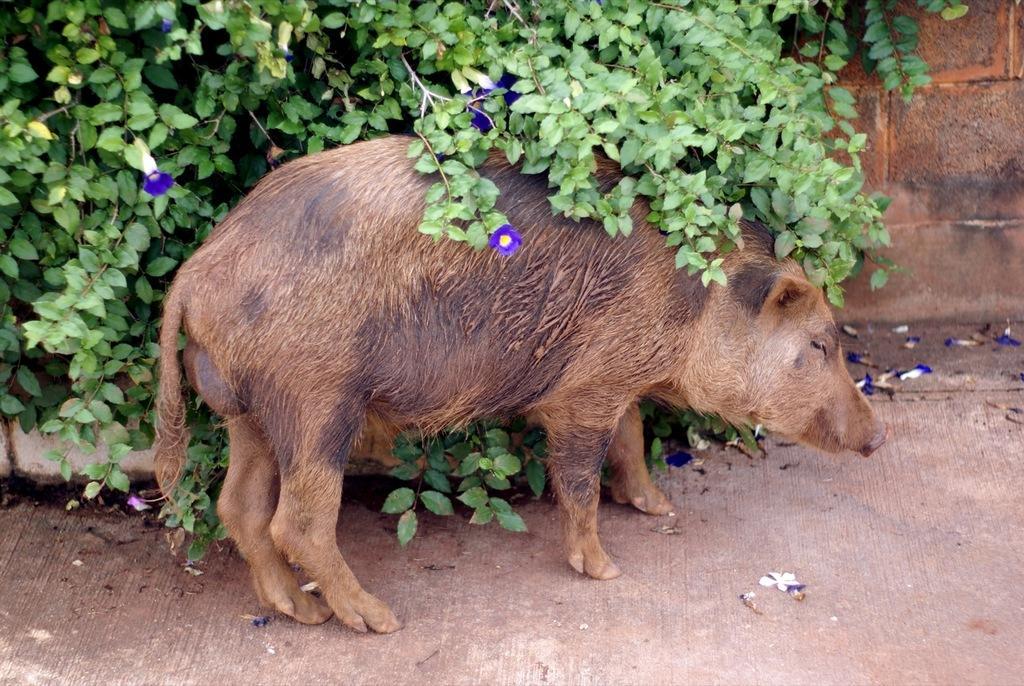Could you give a brief overview of what you see in this image? In this picture we can see a pig in the front, on the left side there are leaves and flowers, on the right side we can see a wall. 